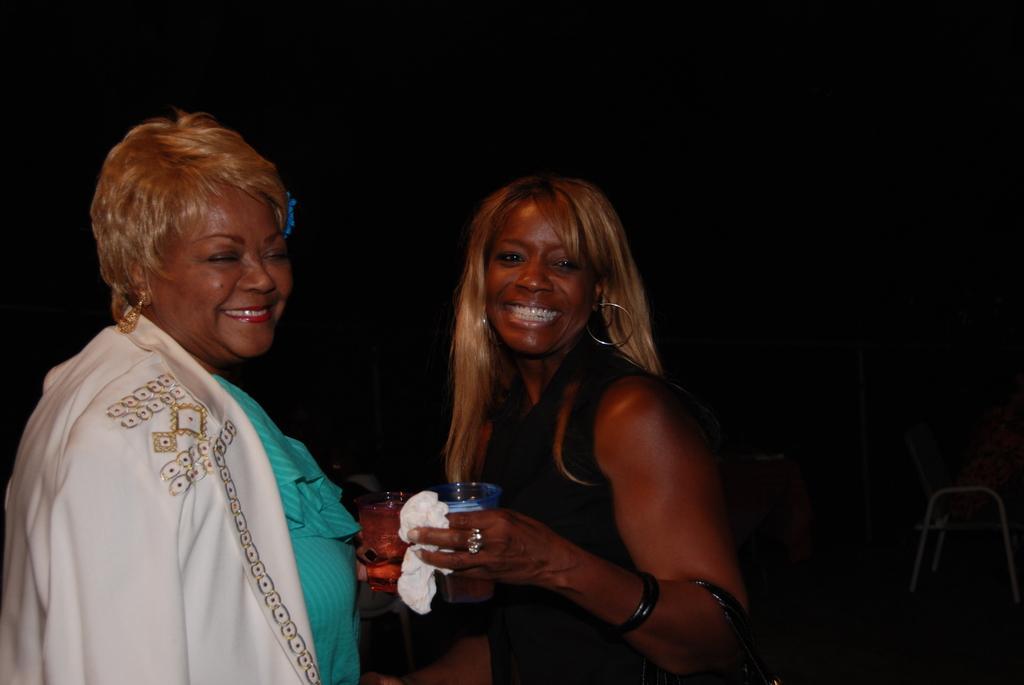Describe this image in one or two sentences. In this image I can see two women standing and smiling. Both are holding glasses in their hands. The background is in black color. 